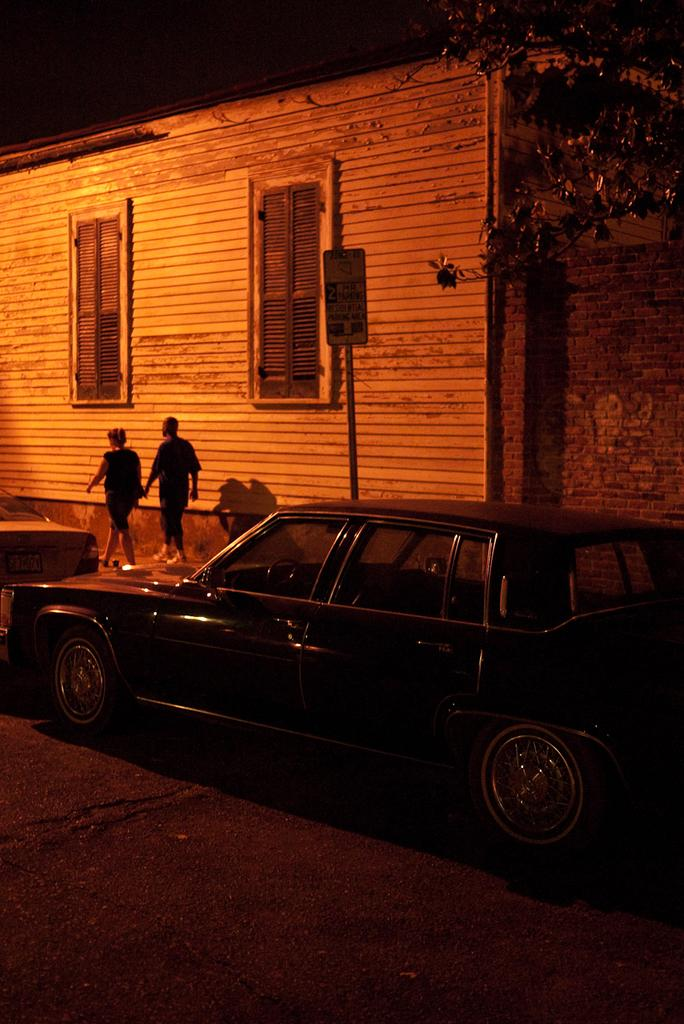What is the main subject of the image? The main subject of the image is a car on the road. Are there any people in the image? Yes, there are two people near the car. What else can be seen in the image besides the car and people? There is a board visible in the image, as well as a tree, a house with windows, and the sky in the background. What is the texture of the hour visible in the image? There is no hour present in the image, and therefore no texture can be determined. 